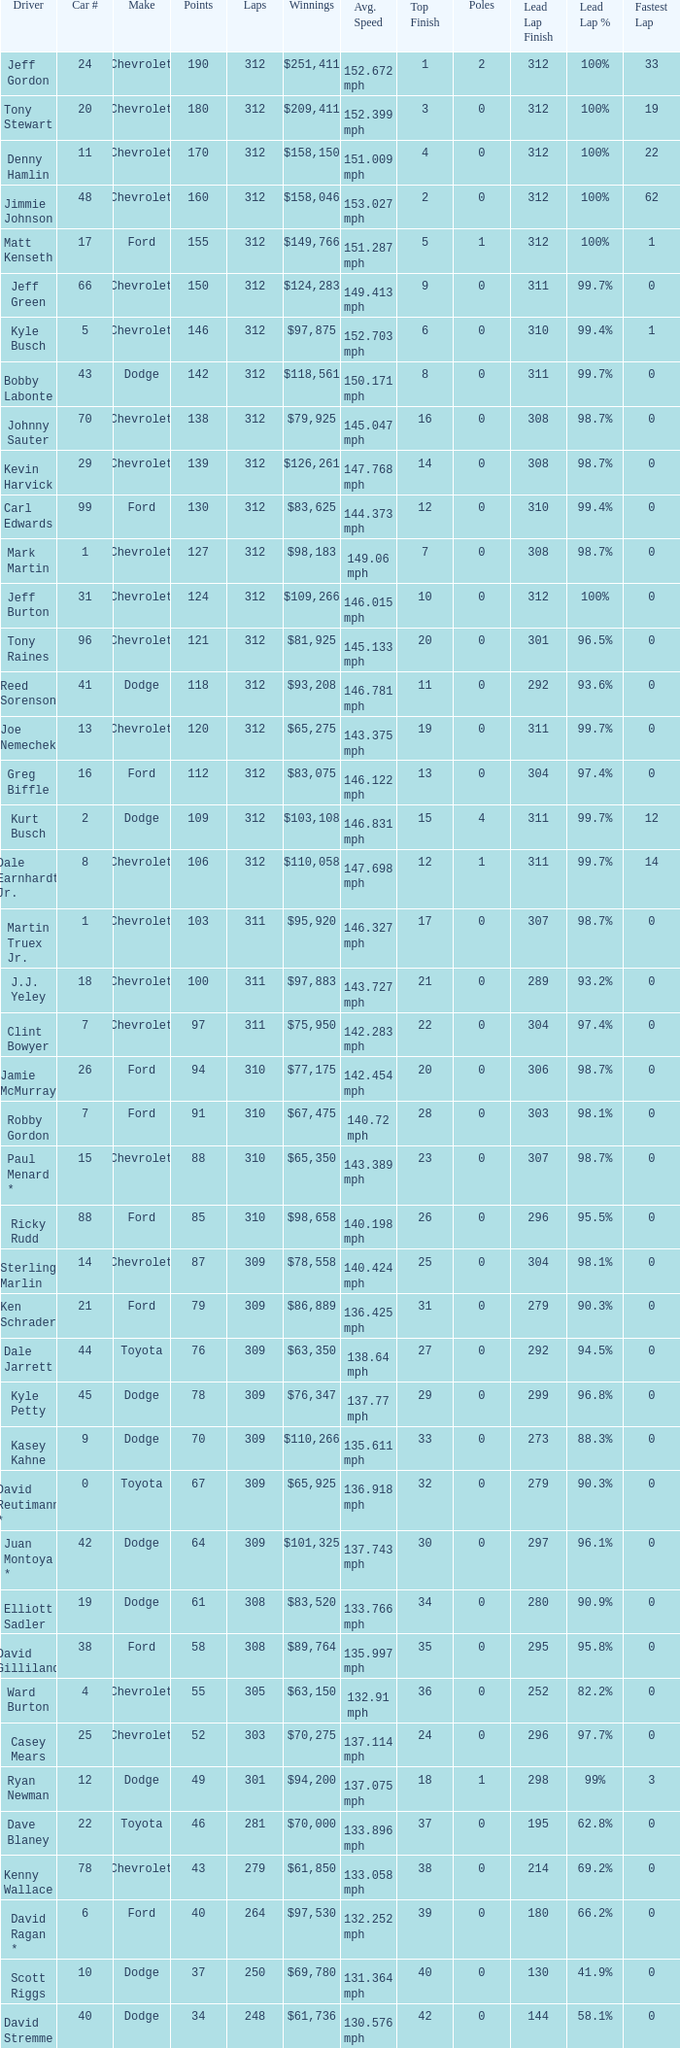What is the lowest number of laps for kyle petty with under 118 points? 309.0. 